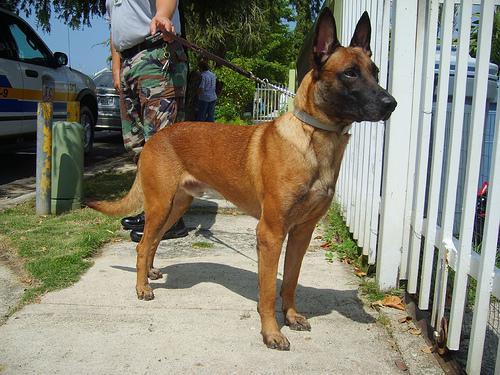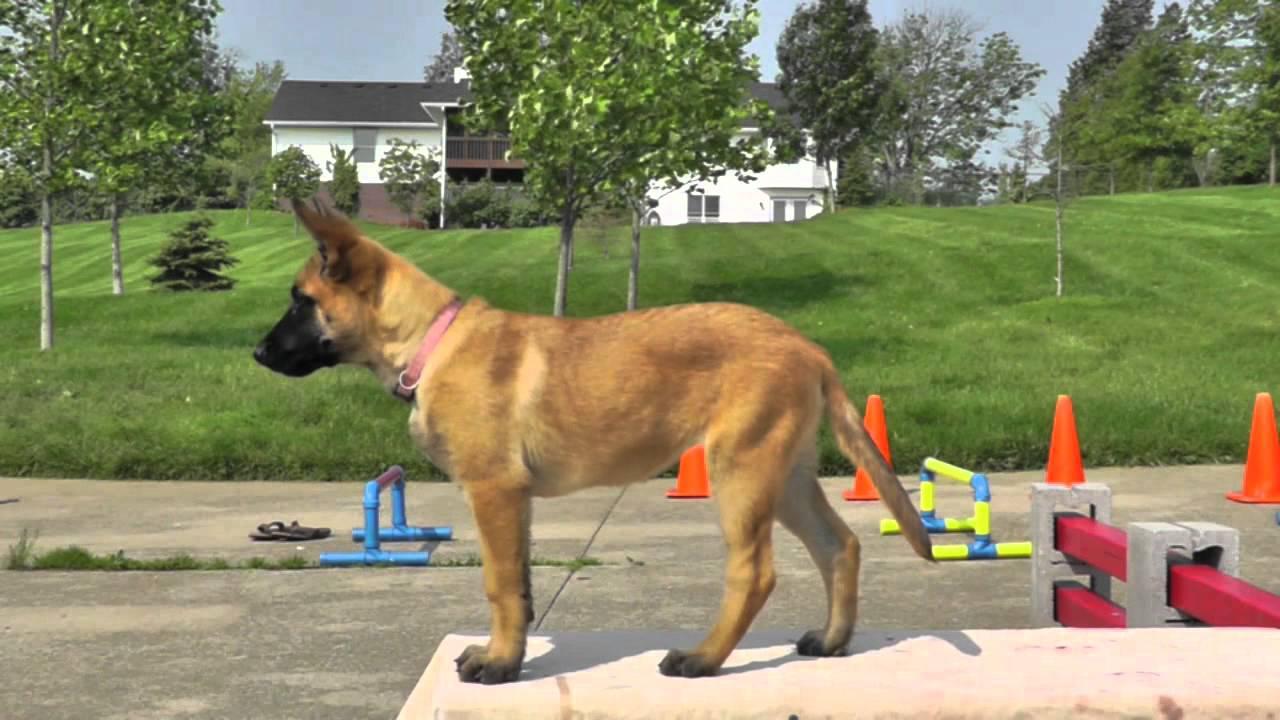The first image is the image on the left, the second image is the image on the right. For the images displayed, is the sentence "One image shows two adult german shepherd dogs posed similarly side-by-side." factually correct? Answer yes or no. No. The first image is the image on the left, the second image is the image on the right. Evaluate the accuracy of this statement regarding the images: "At least one dog is standing near a fence in the image on the left.". Is it true? Answer yes or no. Yes. 